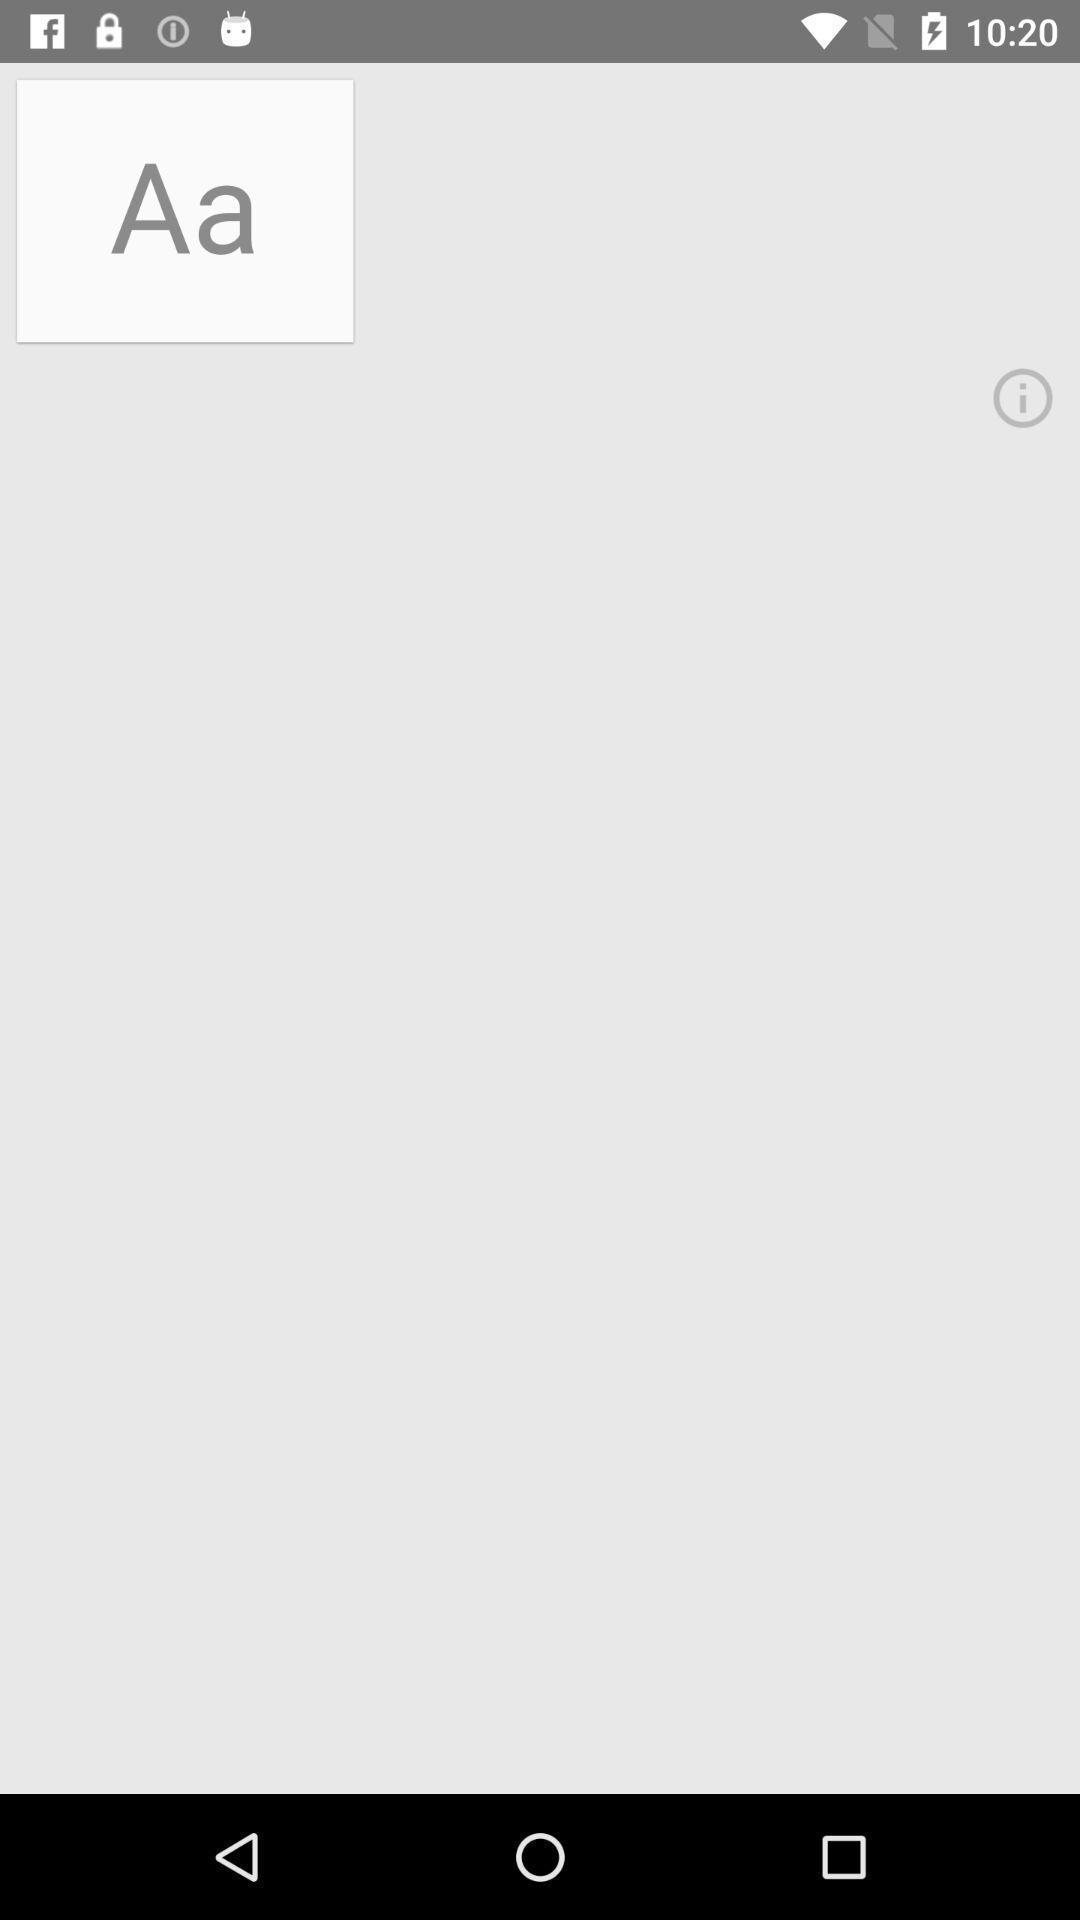Summarize the information in this screenshot. Screen displaying the text font. 